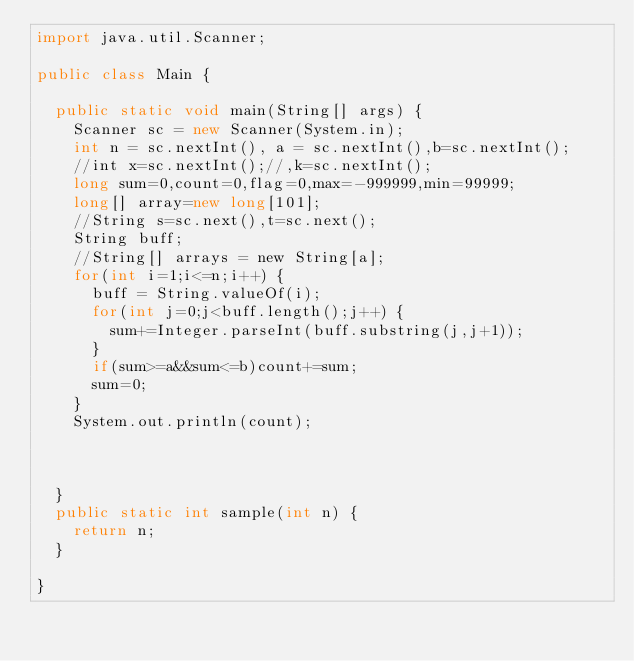Convert code to text. <code><loc_0><loc_0><loc_500><loc_500><_Java_>import java.util.Scanner;

public class Main {

	public static void main(String[] args) {
		Scanner sc = new Scanner(System.in);
		int n = sc.nextInt(), a = sc.nextInt(),b=sc.nextInt();
		//int x=sc.nextInt();//,k=sc.nextInt();
		long sum=0,count=0,flag=0,max=-999999,min=99999;
		long[] array=new long[101];
		//String s=sc.next(),t=sc.next();
		String buff;
		//String[] arrays = new String[a];
		for(int i=1;i<=n;i++) {
			buff = String.valueOf(i);
			for(int j=0;j<buff.length();j++) {
				sum+=Integer.parseInt(buff.substring(j,j+1));
			}
			if(sum>=a&&sum<=b)count+=sum;
			sum=0;
		}
		System.out.println(count);



	}
	public static int sample(int n) {
		return n;
	}

}
</code> 